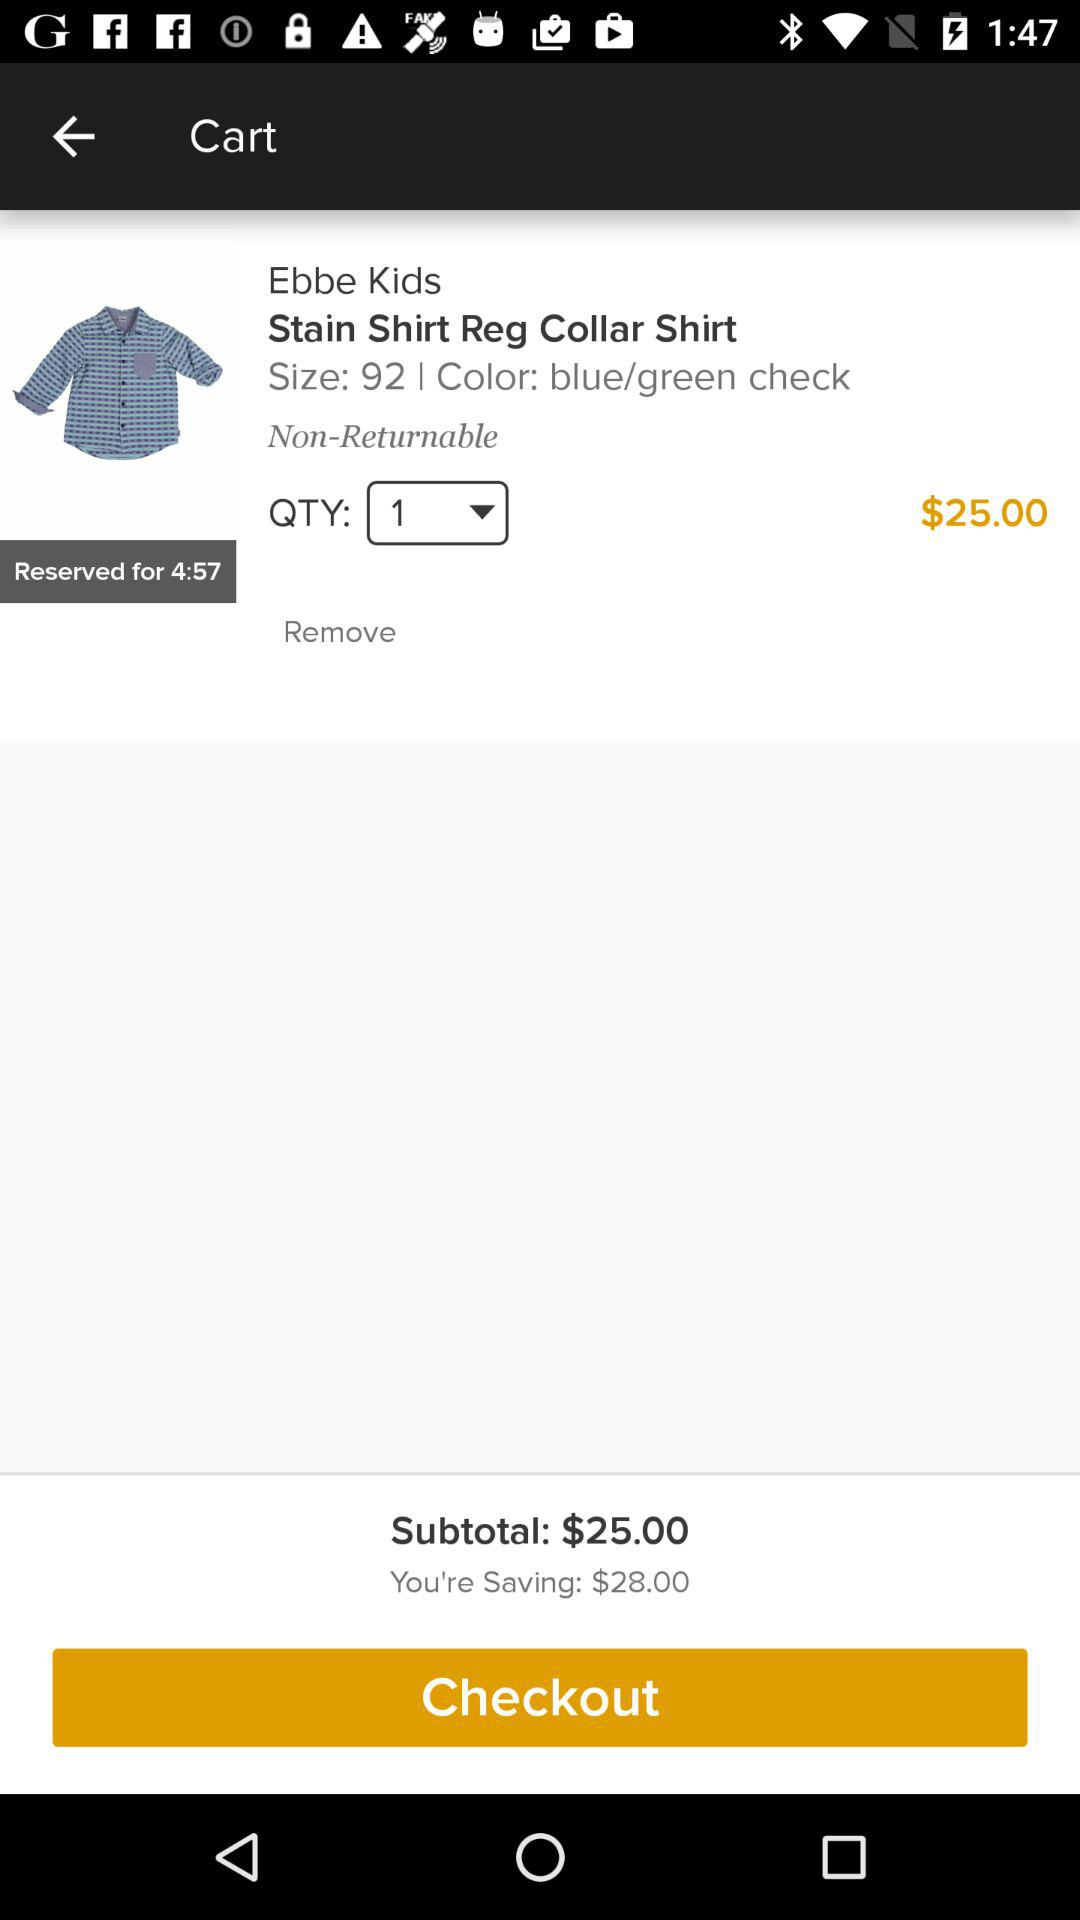What's the color? The color is blue and green. 